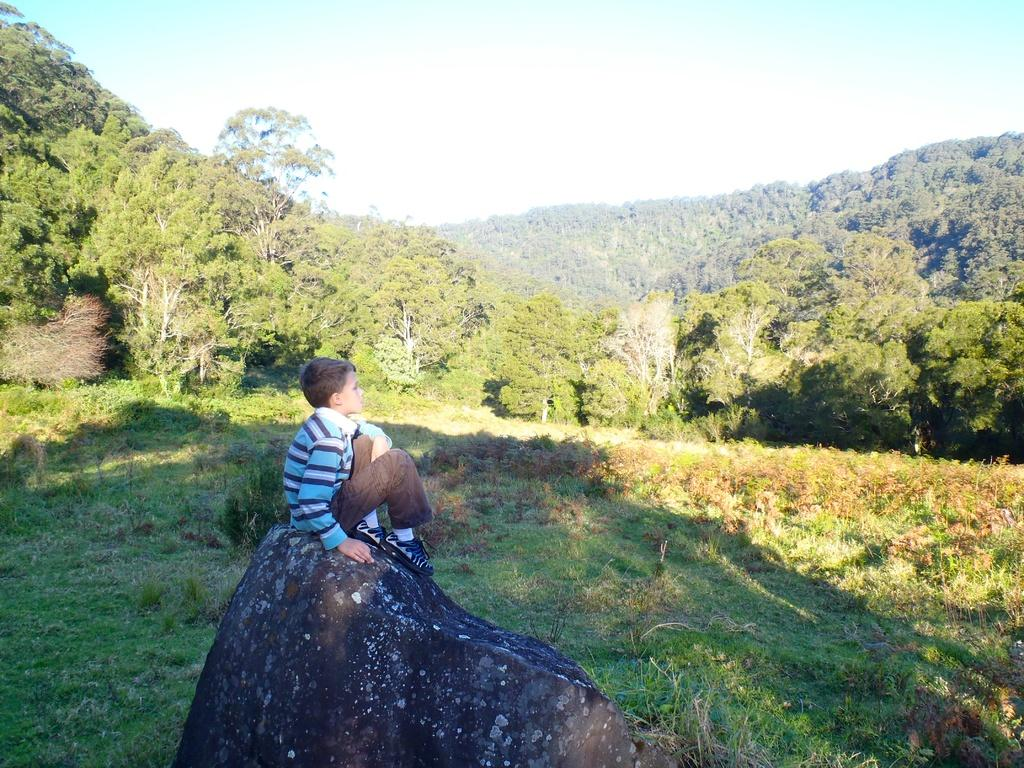What is the boy doing in the image? The boy is sitting on a rock in the image. What can be seen on the ground near the boy? There are plants on the ground in the image. What is visible in the background of the image? There are trees and the sky visible in the background of the image. How many rings can be seen on the boy's fingers in the image? There are no rings visible on the boy's fingers in the image. 